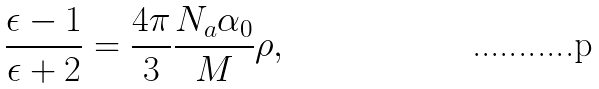Convert formula to latex. <formula><loc_0><loc_0><loc_500><loc_500>\frac { \epsilon - 1 } { \epsilon + 2 } = \frac { 4 \pi } { 3 } \frac { N _ { a } \alpha _ { 0 } } { M } \rho ,</formula> 